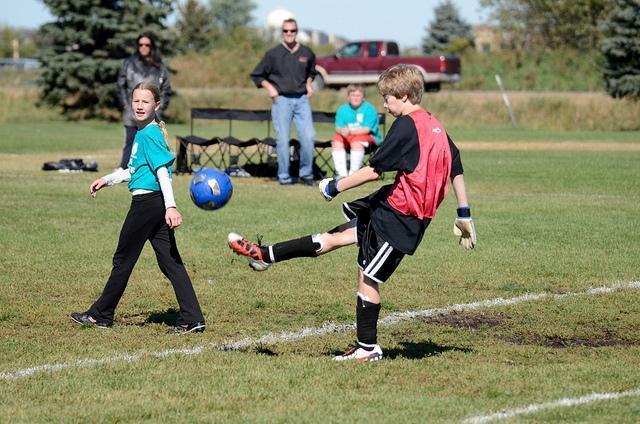How many chairs are in the photo?
Give a very brief answer. 2. How many people are visible?
Give a very brief answer. 5. How many decks does the red bus have?
Give a very brief answer. 0. 